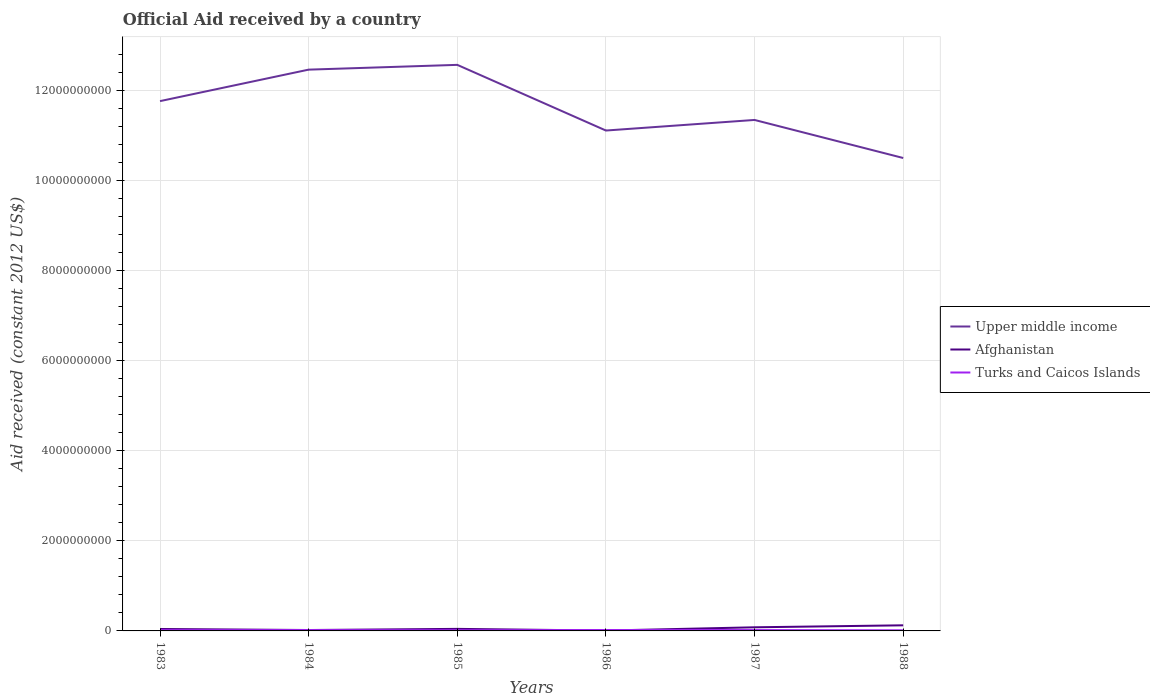How many different coloured lines are there?
Ensure brevity in your answer.  3. Does the line corresponding to Upper middle income intersect with the line corresponding to Afghanistan?
Provide a succinct answer. No. Across all years, what is the maximum net official aid received in Afghanistan?
Your answer should be compact. 7.80e+06. What is the total net official aid received in Afghanistan in the graph?
Provide a short and direct response. -1.05e+08. What is the difference between the highest and the second highest net official aid received in Afghanistan?
Give a very brief answer. 1.17e+08. Is the net official aid received in Upper middle income strictly greater than the net official aid received in Turks and Caicos Islands over the years?
Your answer should be compact. No. What is the difference between two consecutive major ticks on the Y-axis?
Make the answer very short. 2.00e+09. Does the graph contain any zero values?
Offer a terse response. No. Does the graph contain grids?
Your response must be concise. Yes. Where does the legend appear in the graph?
Provide a succinct answer. Center right. How many legend labels are there?
Your answer should be very brief. 3. How are the legend labels stacked?
Your answer should be very brief. Vertical. What is the title of the graph?
Offer a terse response. Official Aid received by a country. What is the label or title of the Y-axis?
Provide a succinct answer. Aid received (constant 2012 US$). What is the Aid received (constant 2012 US$) in Upper middle income in 1983?
Provide a succinct answer. 1.18e+1. What is the Aid received (constant 2012 US$) of Afghanistan in 1983?
Give a very brief answer. 4.30e+07. What is the Aid received (constant 2012 US$) of Turks and Caicos Islands in 1983?
Your answer should be compact. 1.73e+07. What is the Aid received (constant 2012 US$) in Upper middle income in 1984?
Provide a short and direct response. 1.25e+1. What is the Aid received (constant 2012 US$) of Afghanistan in 1984?
Offer a terse response. 2.00e+07. What is the Aid received (constant 2012 US$) of Turks and Caicos Islands in 1984?
Provide a short and direct response. 1.90e+07. What is the Aid received (constant 2012 US$) in Upper middle income in 1985?
Give a very brief answer. 1.26e+1. What is the Aid received (constant 2012 US$) of Afghanistan in 1985?
Give a very brief answer. 4.55e+07. What is the Aid received (constant 2012 US$) in Turks and Caicos Islands in 1985?
Your answer should be very brief. 1.51e+07. What is the Aid received (constant 2012 US$) in Upper middle income in 1986?
Your response must be concise. 1.11e+1. What is the Aid received (constant 2012 US$) of Afghanistan in 1986?
Ensure brevity in your answer.  7.80e+06. What is the Aid received (constant 2012 US$) of Turks and Caicos Islands in 1986?
Ensure brevity in your answer.  2.06e+07. What is the Aid received (constant 2012 US$) in Upper middle income in 1987?
Offer a terse response. 1.13e+1. What is the Aid received (constant 2012 US$) of Afghanistan in 1987?
Offer a very short reply. 8.06e+07. What is the Aid received (constant 2012 US$) in Turks and Caicos Islands in 1987?
Keep it short and to the point. 1.90e+07. What is the Aid received (constant 2012 US$) in Upper middle income in 1988?
Your response must be concise. 1.05e+1. What is the Aid received (constant 2012 US$) in Afghanistan in 1988?
Ensure brevity in your answer.  1.25e+08. What is the Aid received (constant 2012 US$) in Turks and Caicos Islands in 1988?
Make the answer very short. 1.37e+07. Across all years, what is the maximum Aid received (constant 2012 US$) in Upper middle income?
Provide a succinct answer. 1.26e+1. Across all years, what is the maximum Aid received (constant 2012 US$) of Afghanistan?
Your response must be concise. 1.25e+08. Across all years, what is the maximum Aid received (constant 2012 US$) in Turks and Caicos Islands?
Offer a very short reply. 2.06e+07. Across all years, what is the minimum Aid received (constant 2012 US$) in Upper middle income?
Your answer should be compact. 1.05e+1. Across all years, what is the minimum Aid received (constant 2012 US$) in Afghanistan?
Provide a succinct answer. 7.80e+06. Across all years, what is the minimum Aid received (constant 2012 US$) in Turks and Caicos Islands?
Provide a succinct answer. 1.37e+07. What is the total Aid received (constant 2012 US$) in Upper middle income in the graph?
Give a very brief answer. 6.97e+1. What is the total Aid received (constant 2012 US$) of Afghanistan in the graph?
Your response must be concise. 3.22e+08. What is the total Aid received (constant 2012 US$) in Turks and Caicos Islands in the graph?
Provide a short and direct response. 1.05e+08. What is the difference between the Aid received (constant 2012 US$) in Upper middle income in 1983 and that in 1984?
Provide a succinct answer. -6.99e+08. What is the difference between the Aid received (constant 2012 US$) in Afghanistan in 1983 and that in 1984?
Your answer should be compact. 2.30e+07. What is the difference between the Aid received (constant 2012 US$) of Turks and Caicos Islands in 1983 and that in 1984?
Provide a short and direct response. -1.69e+06. What is the difference between the Aid received (constant 2012 US$) in Upper middle income in 1983 and that in 1985?
Your response must be concise. -8.05e+08. What is the difference between the Aid received (constant 2012 US$) in Afghanistan in 1983 and that in 1985?
Your answer should be compact. -2.43e+06. What is the difference between the Aid received (constant 2012 US$) in Turks and Caicos Islands in 1983 and that in 1985?
Offer a terse response. 2.15e+06. What is the difference between the Aid received (constant 2012 US$) in Upper middle income in 1983 and that in 1986?
Offer a terse response. 6.53e+08. What is the difference between the Aid received (constant 2012 US$) of Afghanistan in 1983 and that in 1986?
Offer a terse response. 3.52e+07. What is the difference between the Aid received (constant 2012 US$) of Turks and Caicos Islands in 1983 and that in 1986?
Your answer should be compact. -3.29e+06. What is the difference between the Aid received (constant 2012 US$) of Upper middle income in 1983 and that in 1987?
Your answer should be very brief. 4.18e+08. What is the difference between the Aid received (constant 2012 US$) in Afghanistan in 1983 and that in 1987?
Your answer should be compact. -3.76e+07. What is the difference between the Aid received (constant 2012 US$) in Turks and Caicos Islands in 1983 and that in 1987?
Offer a very short reply. -1.77e+06. What is the difference between the Aid received (constant 2012 US$) of Upper middle income in 1983 and that in 1988?
Ensure brevity in your answer.  1.26e+09. What is the difference between the Aid received (constant 2012 US$) in Afghanistan in 1983 and that in 1988?
Give a very brief answer. -8.16e+07. What is the difference between the Aid received (constant 2012 US$) of Turks and Caicos Islands in 1983 and that in 1988?
Provide a succinct answer. 3.59e+06. What is the difference between the Aid received (constant 2012 US$) in Upper middle income in 1984 and that in 1985?
Your answer should be compact. -1.06e+08. What is the difference between the Aid received (constant 2012 US$) in Afghanistan in 1984 and that in 1985?
Keep it short and to the point. -2.54e+07. What is the difference between the Aid received (constant 2012 US$) of Turks and Caicos Islands in 1984 and that in 1985?
Make the answer very short. 3.84e+06. What is the difference between the Aid received (constant 2012 US$) in Upper middle income in 1984 and that in 1986?
Keep it short and to the point. 1.35e+09. What is the difference between the Aid received (constant 2012 US$) in Afghanistan in 1984 and that in 1986?
Provide a succinct answer. 1.22e+07. What is the difference between the Aid received (constant 2012 US$) of Turks and Caicos Islands in 1984 and that in 1986?
Keep it short and to the point. -1.60e+06. What is the difference between the Aid received (constant 2012 US$) in Upper middle income in 1984 and that in 1987?
Offer a terse response. 1.12e+09. What is the difference between the Aid received (constant 2012 US$) in Afghanistan in 1984 and that in 1987?
Your response must be concise. -6.06e+07. What is the difference between the Aid received (constant 2012 US$) in Upper middle income in 1984 and that in 1988?
Provide a succinct answer. 1.96e+09. What is the difference between the Aid received (constant 2012 US$) in Afghanistan in 1984 and that in 1988?
Your answer should be very brief. -1.05e+08. What is the difference between the Aid received (constant 2012 US$) in Turks and Caicos Islands in 1984 and that in 1988?
Provide a short and direct response. 5.28e+06. What is the difference between the Aid received (constant 2012 US$) of Upper middle income in 1985 and that in 1986?
Keep it short and to the point. 1.46e+09. What is the difference between the Aid received (constant 2012 US$) of Afghanistan in 1985 and that in 1986?
Make the answer very short. 3.77e+07. What is the difference between the Aid received (constant 2012 US$) of Turks and Caicos Islands in 1985 and that in 1986?
Offer a very short reply. -5.44e+06. What is the difference between the Aid received (constant 2012 US$) of Upper middle income in 1985 and that in 1987?
Ensure brevity in your answer.  1.22e+09. What is the difference between the Aid received (constant 2012 US$) of Afghanistan in 1985 and that in 1987?
Your response must be concise. -3.51e+07. What is the difference between the Aid received (constant 2012 US$) in Turks and Caicos Islands in 1985 and that in 1987?
Offer a very short reply. -3.92e+06. What is the difference between the Aid received (constant 2012 US$) of Upper middle income in 1985 and that in 1988?
Provide a succinct answer. 2.07e+09. What is the difference between the Aid received (constant 2012 US$) in Afghanistan in 1985 and that in 1988?
Make the answer very short. -7.92e+07. What is the difference between the Aid received (constant 2012 US$) in Turks and Caicos Islands in 1985 and that in 1988?
Your answer should be very brief. 1.44e+06. What is the difference between the Aid received (constant 2012 US$) of Upper middle income in 1986 and that in 1987?
Ensure brevity in your answer.  -2.35e+08. What is the difference between the Aid received (constant 2012 US$) in Afghanistan in 1986 and that in 1987?
Your answer should be compact. -7.28e+07. What is the difference between the Aid received (constant 2012 US$) in Turks and Caicos Islands in 1986 and that in 1987?
Your answer should be compact. 1.52e+06. What is the difference between the Aid received (constant 2012 US$) in Upper middle income in 1986 and that in 1988?
Keep it short and to the point. 6.10e+08. What is the difference between the Aid received (constant 2012 US$) of Afghanistan in 1986 and that in 1988?
Your answer should be compact. -1.17e+08. What is the difference between the Aid received (constant 2012 US$) of Turks and Caicos Islands in 1986 and that in 1988?
Your answer should be very brief. 6.88e+06. What is the difference between the Aid received (constant 2012 US$) in Upper middle income in 1987 and that in 1988?
Make the answer very short. 8.45e+08. What is the difference between the Aid received (constant 2012 US$) of Afghanistan in 1987 and that in 1988?
Ensure brevity in your answer.  -4.40e+07. What is the difference between the Aid received (constant 2012 US$) in Turks and Caicos Islands in 1987 and that in 1988?
Ensure brevity in your answer.  5.36e+06. What is the difference between the Aid received (constant 2012 US$) of Upper middle income in 1983 and the Aid received (constant 2012 US$) of Afghanistan in 1984?
Offer a terse response. 1.17e+1. What is the difference between the Aid received (constant 2012 US$) in Upper middle income in 1983 and the Aid received (constant 2012 US$) in Turks and Caicos Islands in 1984?
Your answer should be compact. 1.17e+1. What is the difference between the Aid received (constant 2012 US$) in Afghanistan in 1983 and the Aid received (constant 2012 US$) in Turks and Caicos Islands in 1984?
Offer a terse response. 2.41e+07. What is the difference between the Aid received (constant 2012 US$) in Upper middle income in 1983 and the Aid received (constant 2012 US$) in Afghanistan in 1985?
Provide a short and direct response. 1.17e+1. What is the difference between the Aid received (constant 2012 US$) in Upper middle income in 1983 and the Aid received (constant 2012 US$) in Turks and Caicos Islands in 1985?
Keep it short and to the point. 1.17e+1. What is the difference between the Aid received (constant 2012 US$) of Afghanistan in 1983 and the Aid received (constant 2012 US$) of Turks and Caicos Islands in 1985?
Your response must be concise. 2.79e+07. What is the difference between the Aid received (constant 2012 US$) of Upper middle income in 1983 and the Aid received (constant 2012 US$) of Afghanistan in 1986?
Provide a short and direct response. 1.18e+1. What is the difference between the Aid received (constant 2012 US$) in Upper middle income in 1983 and the Aid received (constant 2012 US$) in Turks and Caicos Islands in 1986?
Make the answer very short. 1.17e+1. What is the difference between the Aid received (constant 2012 US$) in Afghanistan in 1983 and the Aid received (constant 2012 US$) in Turks and Caicos Islands in 1986?
Ensure brevity in your answer.  2.25e+07. What is the difference between the Aid received (constant 2012 US$) of Upper middle income in 1983 and the Aid received (constant 2012 US$) of Afghanistan in 1987?
Provide a succinct answer. 1.17e+1. What is the difference between the Aid received (constant 2012 US$) in Upper middle income in 1983 and the Aid received (constant 2012 US$) in Turks and Caicos Islands in 1987?
Keep it short and to the point. 1.17e+1. What is the difference between the Aid received (constant 2012 US$) in Afghanistan in 1983 and the Aid received (constant 2012 US$) in Turks and Caicos Islands in 1987?
Ensure brevity in your answer.  2.40e+07. What is the difference between the Aid received (constant 2012 US$) in Upper middle income in 1983 and the Aid received (constant 2012 US$) in Afghanistan in 1988?
Offer a terse response. 1.16e+1. What is the difference between the Aid received (constant 2012 US$) in Upper middle income in 1983 and the Aid received (constant 2012 US$) in Turks and Caicos Islands in 1988?
Your response must be concise. 1.17e+1. What is the difference between the Aid received (constant 2012 US$) in Afghanistan in 1983 and the Aid received (constant 2012 US$) in Turks and Caicos Islands in 1988?
Provide a succinct answer. 2.94e+07. What is the difference between the Aid received (constant 2012 US$) in Upper middle income in 1984 and the Aid received (constant 2012 US$) in Afghanistan in 1985?
Provide a short and direct response. 1.24e+1. What is the difference between the Aid received (constant 2012 US$) in Upper middle income in 1984 and the Aid received (constant 2012 US$) in Turks and Caicos Islands in 1985?
Provide a short and direct response. 1.24e+1. What is the difference between the Aid received (constant 2012 US$) in Afghanistan in 1984 and the Aid received (constant 2012 US$) in Turks and Caicos Islands in 1985?
Provide a short and direct response. 4.90e+06. What is the difference between the Aid received (constant 2012 US$) of Upper middle income in 1984 and the Aid received (constant 2012 US$) of Afghanistan in 1986?
Give a very brief answer. 1.24e+1. What is the difference between the Aid received (constant 2012 US$) in Upper middle income in 1984 and the Aid received (constant 2012 US$) in Turks and Caicos Islands in 1986?
Ensure brevity in your answer.  1.24e+1. What is the difference between the Aid received (constant 2012 US$) of Afghanistan in 1984 and the Aid received (constant 2012 US$) of Turks and Caicos Islands in 1986?
Give a very brief answer. -5.40e+05. What is the difference between the Aid received (constant 2012 US$) in Upper middle income in 1984 and the Aid received (constant 2012 US$) in Afghanistan in 1987?
Your answer should be very brief. 1.24e+1. What is the difference between the Aid received (constant 2012 US$) of Upper middle income in 1984 and the Aid received (constant 2012 US$) of Turks and Caicos Islands in 1987?
Offer a very short reply. 1.24e+1. What is the difference between the Aid received (constant 2012 US$) of Afghanistan in 1984 and the Aid received (constant 2012 US$) of Turks and Caicos Islands in 1987?
Provide a succinct answer. 9.80e+05. What is the difference between the Aid received (constant 2012 US$) of Upper middle income in 1984 and the Aid received (constant 2012 US$) of Afghanistan in 1988?
Ensure brevity in your answer.  1.23e+1. What is the difference between the Aid received (constant 2012 US$) of Upper middle income in 1984 and the Aid received (constant 2012 US$) of Turks and Caicos Islands in 1988?
Offer a very short reply. 1.24e+1. What is the difference between the Aid received (constant 2012 US$) in Afghanistan in 1984 and the Aid received (constant 2012 US$) in Turks and Caicos Islands in 1988?
Offer a very short reply. 6.34e+06. What is the difference between the Aid received (constant 2012 US$) in Upper middle income in 1985 and the Aid received (constant 2012 US$) in Afghanistan in 1986?
Ensure brevity in your answer.  1.26e+1. What is the difference between the Aid received (constant 2012 US$) in Upper middle income in 1985 and the Aid received (constant 2012 US$) in Turks and Caicos Islands in 1986?
Keep it short and to the point. 1.25e+1. What is the difference between the Aid received (constant 2012 US$) of Afghanistan in 1985 and the Aid received (constant 2012 US$) of Turks and Caicos Islands in 1986?
Offer a terse response. 2.49e+07. What is the difference between the Aid received (constant 2012 US$) in Upper middle income in 1985 and the Aid received (constant 2012 US$) in Afghanistan in 1987?
Provide a succinct answer. 1.25e+1. What is the difference between the Aid received (constant 2012 US$) of Upper middle income in 1985 and the Aid received (constant 2012 US$) of Turks and Caicos Islands in 1987?
Provide a succinct answer. 1.25e+1. What is the difference between the Aid received (constant 2012 US$) in Afghanistan in 1985 and the Aid received (constant 2012 US$) in Turks and Caicos Islands in 1987?
Give a very brief answer. 2.64e+07. What is the difference between the Aid received (constant 2012 US$) of Upper middle income in 1985 and the Aid received (constant 2012 US$) of Afghanistan in 1988?
Keep it short and to the point. 1.24e+1. What is the difference between the Aid received (constant 2012 US$) in Upper middle income in 1985 and the Aid received (constant 2012 US$) in Turks and Caicos Islands in 1988?
Provide a succinct answer. 1.26e+1. What is the difference between the Aid received (constant 2012 US$) of Afghanistan in 1985 and the Aid received (constant 2012 US$) of Turks and Caicos Islands in 1988?
Your response must be concise. 3.18e+07. What is the difference between the Aid received (constant 2012 US$) of Upper middle income in 1986 and the Aid received (constant 2012 US$) of Afghanistan in 1987?
Your answer should be very brief. 1.10e+1. What is the difference between the Aid received (constant 2012 US$) of Upper middle income in 1986 and the Aid received (constant 2012 US$) of Turks and Caicos Islands in 1987?
Provide a succinct answer. 1.11e+1. What is the difference between the Aid received (constant 2012 US$) of Afghanistan in 1986 and the Aid received (constant 2012 US$) of Turks and Caicos Islands in 1987?
Your answer should be compact. -1.12e+07. What is the difference between the Aid received (constant 2012 US$) in Upper middle income in 1986 and the Aid received (constant 2012 US$) in Afghanistan in 1988?
Give a very brief answer. 1.10e+1. What is the difference between the Aid received (constant 2012 US$) of Upper middle income in 1986 and the Aid received (constant 2012 US$) of Turks and Caicos Islands in 1988?
Your answer should be very brief. 1.11e+1. What is the difference between the Aid received (constant 2012 US$) in Afghanistan in 1986 and the Aid received (constant 2012 US$) in Turks and Caicos Islands in 1988?
Make the answer very short. -5.89e+06. What is the difference between the Aid received (constant 2012 US$) of Upper middle income in 1987 and the Aid received (constant 2012 US$) of Afghanistan in 1988?
Your answer should be compact. 1.12e+1. What is the difference between the Aid received (constant 2012 US$) of Upper middle income in 1987 and the Aid received (constant 2012 US$) of Turks and Caicos Islands in 1988?
Your answer should be very brief. 1.13e+1. What is the difference between the Aid received (constant 2012 US$) in Afghanistan in 1987 and the Aid received (constant 2012 US$) in Turks and Caicos Islands in 1988?
Your answer should be compact. 6.69e+07. What is the average Aid received (constant 2012 US$) of Upper middle income per year?
Provide a succinct answer. 1.16e+1. What is the average Aid received (constant 2012 US$) in Afghanistan per year?
Your response must be concise. 5.36e+07. What is the average Aid received (constant 2012 US$) in Turks and Caicos Islands per year?
Offer a very short reply. 1.74e+07. In the year 1983, what is the difference between the Aid received (constant 2012 US$) in Upper middle income and Aid received (constant 2012 US$) in Afghanistan?
Ensure brevity in your answer.  1.17e+1. In the year 1983, what is the difference between the Aid received (constant 2012 US$) of Upper middle income and Aid received (constant 2012 US$) of Turks and Caicos Islands?
Your answer should be very brief. 1.17e+1. In the year 1983, what is the difference between the Aid received (constant 2012 US$) in Afghanistan and Aid received (constant 2012 US$) in Turks and Caicos Islands?
Offer a very short reply. 2.58e+07. In the year 1984, what is the difference between the Aid received (constant 2012 US$) of Upper middle income and Aid received (constant 2012 US$) of Afghanistan?
Your answer should be compact. 1.24e+1. In the year 1984, what is the difference between the Aid received (constant 2012 US$) in Upper middle income and Aid received (constant 2012 US$) in Turks and Caicos Islands?
Give a very brief answer. 1.24e+1. In the year 1984, what is the difference between the Aid received (constant 2012 US$) in Afghanistan and Aid received (constant 2012 US$) in Turks and Caicos Islands?
Give a very brief answer. 1.06e+06. In the year 1985, what is the difference between the Aid received (constant 2012 US$) of Upper middle income and Aid received (constant 2012 US$) of Afghanistan?
Your answer should be compact. 1.25e+1. In the year 1985, what is the difference between the Aid received (constant 2012 US$) in Upper middle income and Aid received (constant 2012 US$) in Turks and Caicos Islands?
Your answer should be very brief. 1.25e+1. In the year 1985, what is the difference between the Aid received (constant 2012 US$) in Afghanistan and Aid received (constant 2012 US$) in Turks and Caicos Islands?
Keep it short and to the point. 3.03e+07. In the year 1986, what is the difference between the Aid received (constant 2012 US$) of Upper middle income and Aid received (constant 2012 US$) of Afghanistan?
Your answer should be very brief. 1.11e+1. In the year 1986, what is the difference between the Aid received (constant 2012 US$) of Upper middle income and Aid received (constant 2012 US$) of Turks and Caicos Islands?
Provide a short and direct response. 1.11e+1. In the year 1986, what is the difference between the Aid received (constant 2012 US$) of Afghanistan and Aid received (constant 2012 US$) of Turks and Caicos Islands?
Provide a short and direct response. -1.28e+07. In the year 1987, what is the difference between the Aid received (constant 2012 US$) in Upper middle income and Aid received (constant 2012 US$) in Afghanistan?
Keep it short and to the point. 1.13e+1. In the year 1987, what is the difference between the Aid received (constant 2012 US$) in Upper middle income and Aid received (constant 2012 US$) in Turks and Caicos Islands?
Give a very brief answer. 1.13e+1. In the year 1987, what is the difference between the Aid received (constant 2012 US$) in Afghanistan and Aid received (constant 2012 US$) in Turks and Caicos Islands?
Provide a short and direct response. 6.16e+07. In the year 1988, what is the difference between the Aid received (constant 2012 US$) in Upper middle income and Aid received (constant 2012 US$) in Afghanistan?
Ensure brevity in your answer.  1.04e+1. In the year 1988, what is the difference between the Aid received (constant 2012 US$) in Upper middle income and Aid received (constant 2012 US$) in Turks and Caicos Islands?
Your response must be concise. 1.05e+1. In the year 1988, what is the difference between the Aid received (constant 2012 US$) in Afghanistan and Aid received (constant 2012 US$) in Turks and Caicos Islands?
Offer a very short reply. 1.11e+08. What is the ratio of the Aid received (constant 2012 US$) of Upper middle income in 1983 to that in 1984?
Give a very brief answer. 0.94. What is the ratio of the Aid received (constant 2012 US$) of Afghanistan in 1983 to that in 1984?
Your answer should be very brief. 2.15. What is the ratio of the Aid received (constant 2012 US$) of Turks and Caicos Islands in 1983 to that in 1984?
Provide a succinct answer. 0.91. What is the ratio of the Aid received (constant 2012 US$) in Upper middle income in 1983 to that in 1985?
Offer a terse response. 0.94. What is the ratio of the Aid received (constant 2012 US$) in Afghanistan in 1983 to that in 1985?
Your response must be concise. 0.95. What is the ratio of the Aid received (constant 2012 US$) in Turks and Caicos Islands in 1983 to that in 1985?
Keep it short and to the point. 1.14. What is the ratio of the Aid received (constant 2012 US$) in Upper middle income in 1983 to that in 1986?
Your answer should be compact. 1.06. What is the ratio of the Aid received (constant 2012 US$) of Afghanistan in 1983 to that in 1986?
Give a very brief answer. 5.52. What is the ratio of the Aid received (constant 2012 US$) of Turks and Caicos Islands in 1983 to that in 1986?
Offer a terse response. 0.84. What is the ratio of the Aid received (constant 2012 US$) of Upper middle income in 1983 to that in 1987?
Offer a very short reply. 1.04. What is the ratio of the Aid received (constant 2012 US$) in Afghanistan in 1983 to that in 1987?
Offer a terse response. 0.53. What is the ratio of the Aid received (constant 2012 US$) in Turks and Caicos Islands in 1983 to that in 1987?
Keep it short and to the point. 0.91. What is the ratio of the Aid received (constant 2012 US$) in Upper middle income in 1983 to that in 1988?
Ensure brevity in your answer.  1.12. What is the ratio of the Aid received (constant 2012 US$) in Afghanistan in 1983 to that in 1988?
Offer a very short reply. 0.35. What is the ratio of the Aid received (constant 2012 US$) in Turks and Caicos Islands in 1983 to that in 1988?
Offer a terse response. 1.26. What is the ratio of the Aid received (constant 2012 US$) of Upper middle income in 1984 to that in 1985?
Make the answer very short. 0.99. What is the ratio of the Aid received (constant 2012 US$) of Afghanistan in 1984 to that in 1985?
Your answer should be compact. 0.44. What is the ratio of the Aid received (constant 2012 US$) in Turks and Caicos Islands in 1984 to that in 1985?
Offer a very short reply. 1.25. What is the ratio of the Aid received (constant 2012 US$) in Upper middle income in 1984 to that in 1986?
Your response must be concise. 1.12. What is the ratio of the Aid received (constant 2012 US$) of Afghanistan in 1984 to that in 1986?
Ensure brevity in your answer.  2.57. What is the ratio of the Aid received (constant 2012 US$) of Turks and Caicos Islands in 1984 to that in 1986?
Your response must be concise. 0.92. What is the ratio of the Aid received (constant 2012 US$) of Upper middle income in 1984 to that in 1987?
Ensure brevity in your answer.  1.1. What is the ratio of the Aid received (constant 2012 US$) in Afghanistan in 1984 to that in 1987?
Keep it short and to the point. 0.25. What is the ratio of the Aid received (constant 2012 US$) of Upper middle income in 1984 to that in 1988?
Keep it short and to the point. 1.19. What is the ratio of the Aid received (constant 2012 US$) of Afghanistan in 1984 to that in 1988?
Your answer should be compact. 0.16. What is the ratio of the Aid received (constant 2012 US$) in Turks and Caicos Islands in 1984 to that in 1988?
Give a very brief answer. 1.39. What is the ratio of the Aid received (constant 2012 US$) in Upper middle income in 1985 to that in 1986?
Your answer should be compact. 1.13. What is the ratio of the Aid received (constant 2012 US$) in Afghanistan in 1985 to that in 1986?
Ensure brevity in your answer.  5.83. What is the ratio of the Aid received (constant 2012 US$) of Turks and Caicos Islands in 1985 to that in 1986?
Provide a succinct answer. 0.74. What is the ratio of the Aid received (constant 2012 US$) in Upper middle income in 1985 to that in 1987?
Provide a succinct answer. 1.11. What is the ratio of the Aid received (constant 2012 US$) in Afghanistan in 1985 to that in 1987?
Your answer should be very brief. 0.56. What is the ratio of the Aid received (constant 2012 US$) in Turks and Caicos Islands in 1985 to that in 1987?
Make the answer very short. 0.79. What is the ratio of the Aid received (constant 2012 US$) in Upper middle income in 1985 to that in 1988?
Offer a very short reply. 1.2. What is the ratio of the Aid received (constant 2012 US$) of Afghanistan in 1985 to that in 1988?
Your response must be concise. 0.36. What is the ratio of the Aid received (constant 2012 US$) in Turks and Caicos Islands in 1985 to that in 1988?
Keep it short and to the point. 1.11. What is the ratio of the Aid received (constant 2012 US$) of Upper middle income in 1986 to that in 1987?
Keep it short and to the point. 0.98. What is the ratio of the Aid received (constant 2012 US$) of Afghanistan in 1986 to that in 1987?
Give a very brief answer. 0.1. What is the ratio of the Aid received (constant 2012 US$) in Turks and Caicos Islands in 1986 to that in 1987?
Your response must be concise. 1.08. What is the ratio of the Aid received (constant 2012 US$) in Upper middle income in 1986 to that in 1988?
Your response must be concise. 1.06. What is the ratio of the Aid received (constant 2012 US$) in Afghanistan in 1986 to that in 1988?
Provide a short and direct response. 0.06. What is the ratio of the Aid received (constant 2012 US$) of Turks and Caicos Islands in 1986 to that in 1988?
Your answer should be compact. 1.5. What is the ratio of the Aid received (constant 2012 US$) of Upper middle income in 1987 to that in 1988?
Provide a short and direct response. 1.08. What is the ratio of the Aid received (constant 2012 US$) in Afghanistan in 1987 to that in 1988?
Your answer should be very brief. 0.65. What is the ratio of the Aid received (constant 2012 US$) in Turks and Caicos Islands in 1987 to that in 1988?
Offer a very short reply. 1.39. What is the difference between the highest and the second highest Aid received (constant 2012 US$) in Upper middle income?
Your response must be concise. 1.06e+08. What is the difference between the highest and the second highest Aid received (constant 2012 US$) of Afghanistan?
Your answer should be very brief. 4.40e+07. What is the difference between the highest and the second highest Aid received (constant 2012 US$) in Turks and Caicos Islands?
Your answer should be compact. 1.52e+06. What is the difference between the highest and the lowest Aid received (constant 2012 US$) in Upper middle income?
Give a very brief answer. 2.07e+09. What is the difference between the highest and the lowest Aid received (constant 2012 US$) of Afghanistan?
Give a very brief answer. 1.17e+08. What is the difference between the highest and the lowest Aid received (constant 2012 US$) in Turks and Caicos Islands?
Provide a succinct answer. 6.88e+06. 